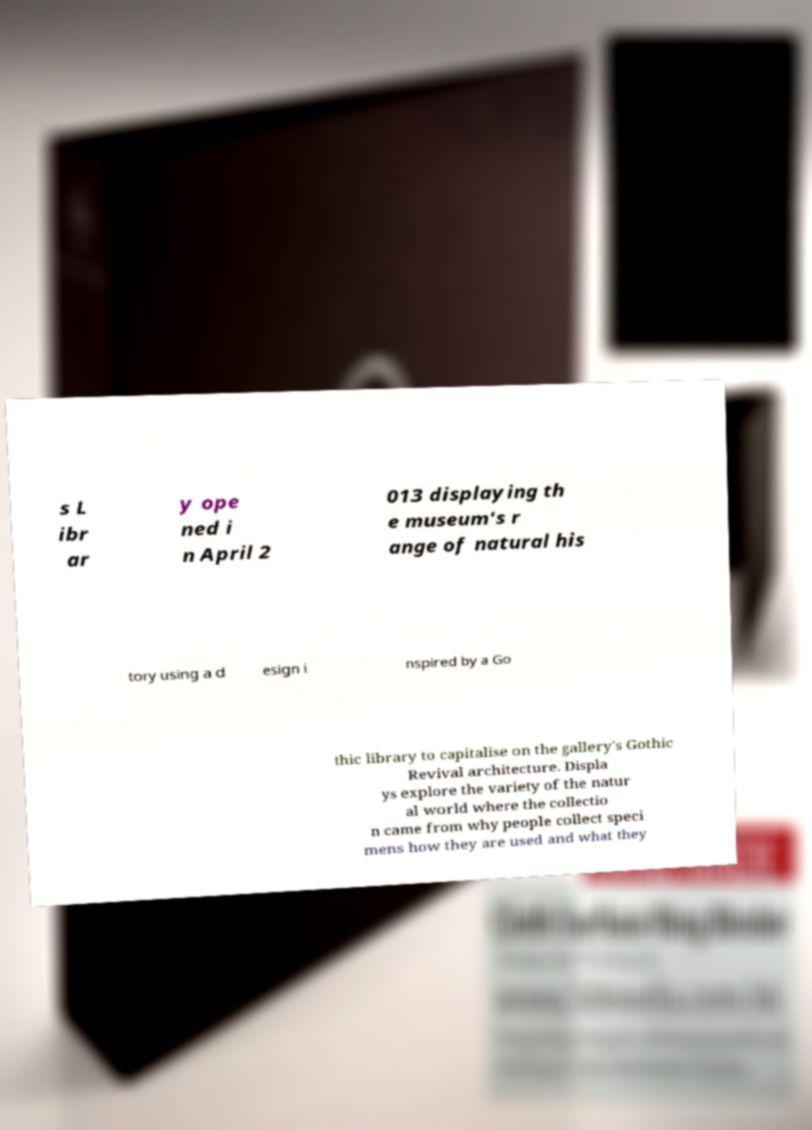Please identify and transcribe the text found in this image. s L ibr ar y ope ned i n April 2 013 displaying th e museum's r ange of natural his tory using a d esign i nspired by a Go thic library to capitalise on the gallery's Gothic Revival architecture. Displa ys explore the variety of the natur al world where the collectio n came from why people collect speci mens how they are used and what they 